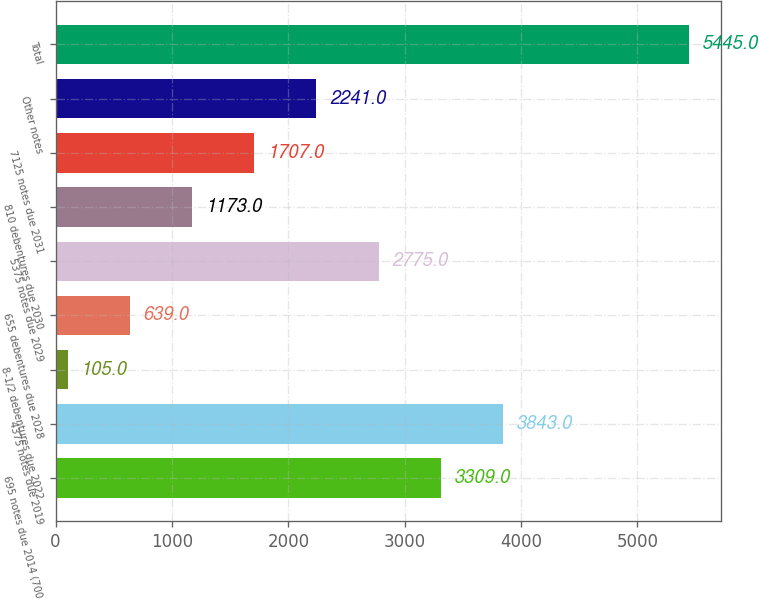Convert chart. <chart><loc_0><loc_0><loc_500><loc_500><bar_chart><fcel>695 notes due 2014 (700<fcel>4375 notes due 2019<fcel>8-1/2 debentures due 2022<fcel>655 debentures due 2028<fcel>5375 notes due 2029<fcel>810 debentures due 2030<fcel>7125 notes due 2031<fcel>Other notes<fcel>Total<nl><fcel>3309<fcel>3843<fcel>105<fcel>639<fcel>2775<fcel>1173<fcel>1707<fcel>2241<fcel>5445<nl></chart> 